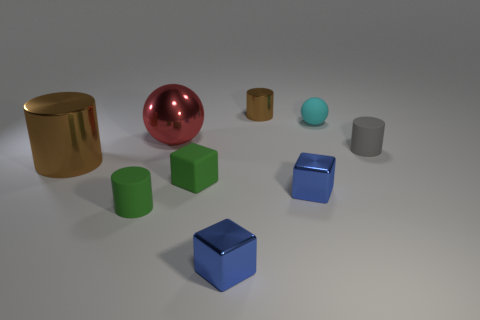Add 1 red objects. How many objects exist? 10 Subtract all balls. How many objects are left? 7 Add 2 tiny spheres. How many tiny spheres exist? 3 Subtract 1 green cylinders. How many objects are left? 8 Subtract all large red objects. Subtract all big cylinders. How many objects are left? 7 Add 8 large brown shiny things. How many large brown shiny things are left? 9 